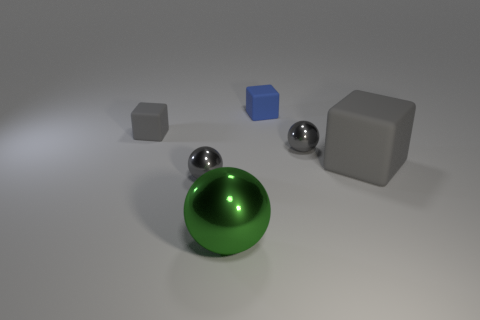Subtract all large balls. How many balls are left? 2 Subtract all gray cylinders. How many gray blocks are left? 2 Subtract 1 blocks. How many blocks are left? 2 Subtract all blue blocks. How many blocks are left? 2 Add 3 tiny gray cubes. How many objects exist? 9 Subtract all blue spheres. Subtract all red cubes. How many spheres are left? 3 Subtract all big gray cylinders. Subtract all gray cubes. How many objects are left? 4 Add 1 small gray matte cubes. How many small gray matte cubes are left? 2 Add 2 gray objects. How many gray objects exist? 6 Subtract 0 brown cubes. How many objects are left? 6 